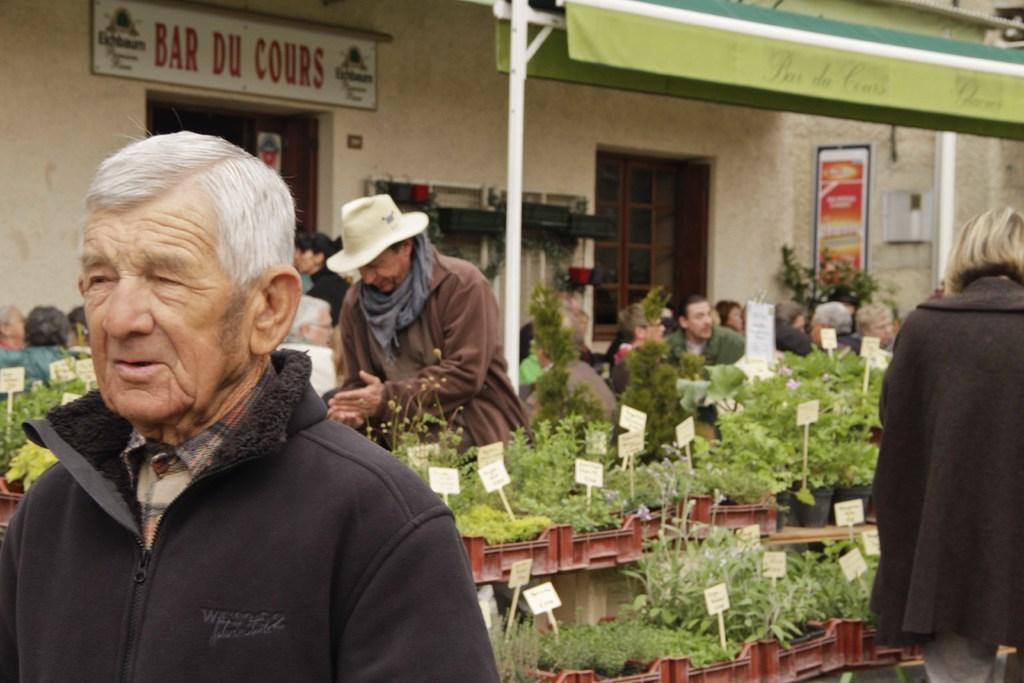Please provide a concise description of this image. In this image we can see many plants and descriptive boards. There is a store and it is having windows. There are many people in the image. There are advertising boards in the image. 